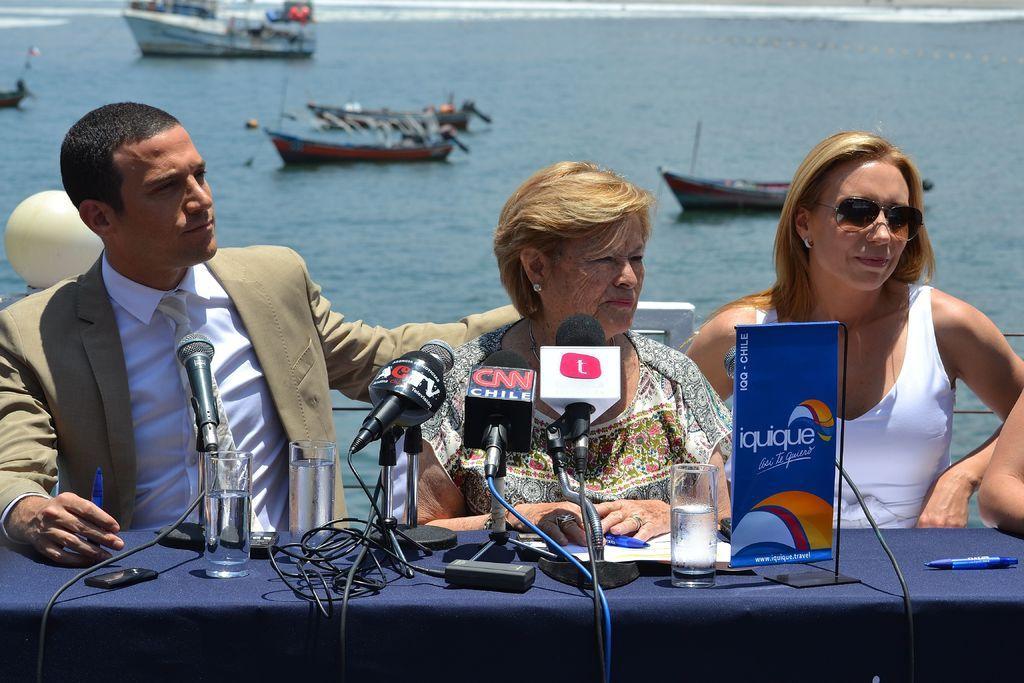In one or two sentences, can you explain what this image depicts? In this image there is a table with mike's, glasses and other objects on it, three people , chairs in the foreground. There is water, ships in the background. 